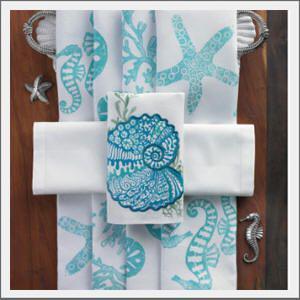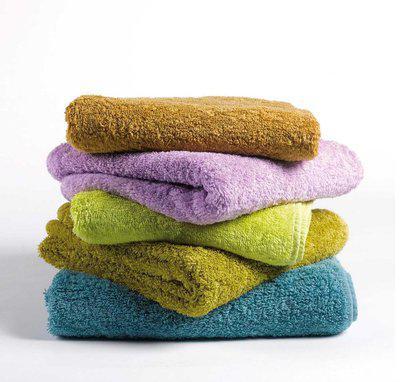The first image is the image on the left, the second image is the image on the right. Considering the images on both sides, is "There is at least one stack of regularly folded towels in each image, with at least 3 different colors of towel per image." valid? Answer yes or no. No. The first image is the image on the left, the second image is the image on the right. For the images shown, is this caption "There is a least two towers of four towels." true? Answer yes or no. No. 